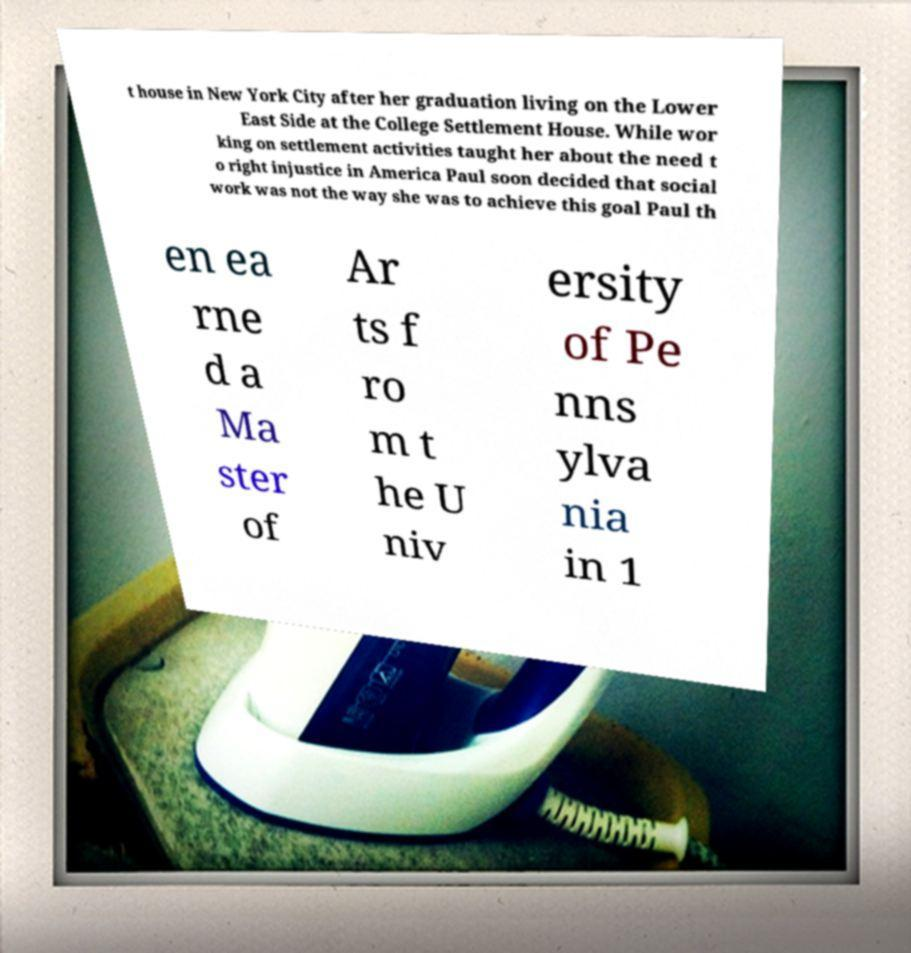Could you extract and type out the text from this image? t house in New York City after her graduation living on the Lower East Side at the College Settlement House. While wor king on settlement activities taught her about the need t o right injustice in America Paul soon decided that social work was not the way she was to achieve this goal Paul th en ea rne d a Ma ster of Ar ts f ro m t he U niv ersity of Pe nns ylva nia in 1 